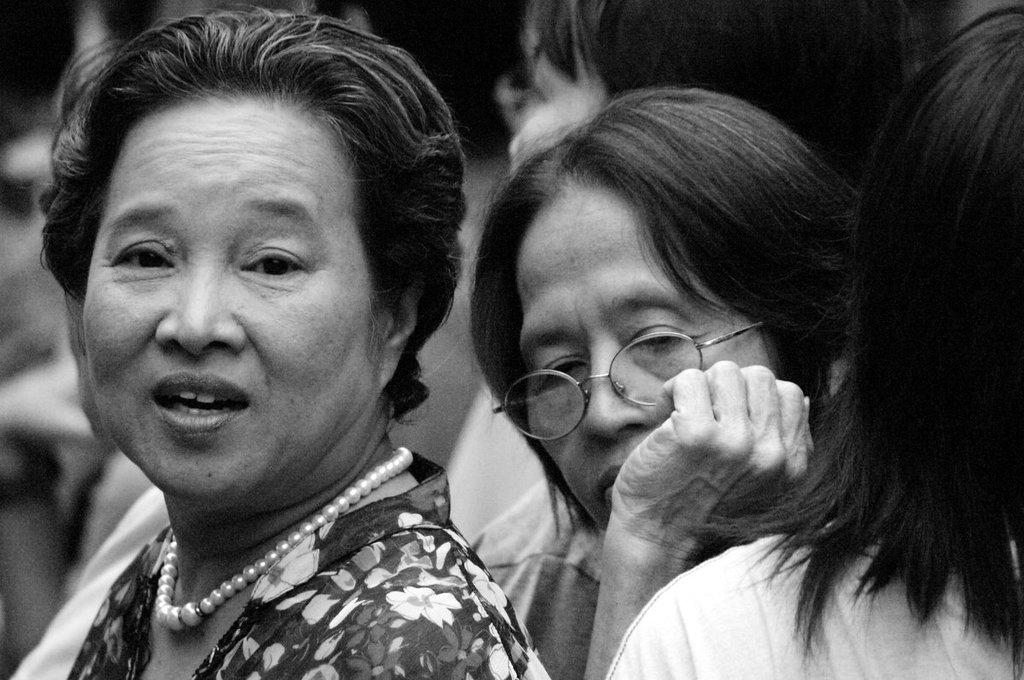How many individuals are present in the image? There is a group of people in the image. What are the people in the image doing? The people are standing. What type of paint is being used to color the slope in the image? There is no slope or paint present in the image; it features a group of people standing. 